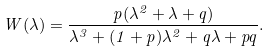Convert formula to latex. <formula><loc_0><loc_0><loc_500><loc_500>W ( \lambda ) = \frac { p ( \lambda ^ { 2 } + \lambda + q ) } { \lambda ^ { 3 } + ( 1 + p ) \lambda ^ { 2 } + q \lambda + p q } .</formula> 